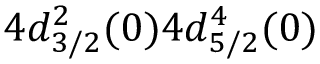<formula> <loc_0><loc_0><loc_500><loc_500>4 d _ { 3 / 2 } ^ { 2 } ( 0 ) 4 d _ { 5 / 2 } ^ { 4 } ( 0 )</formula> 